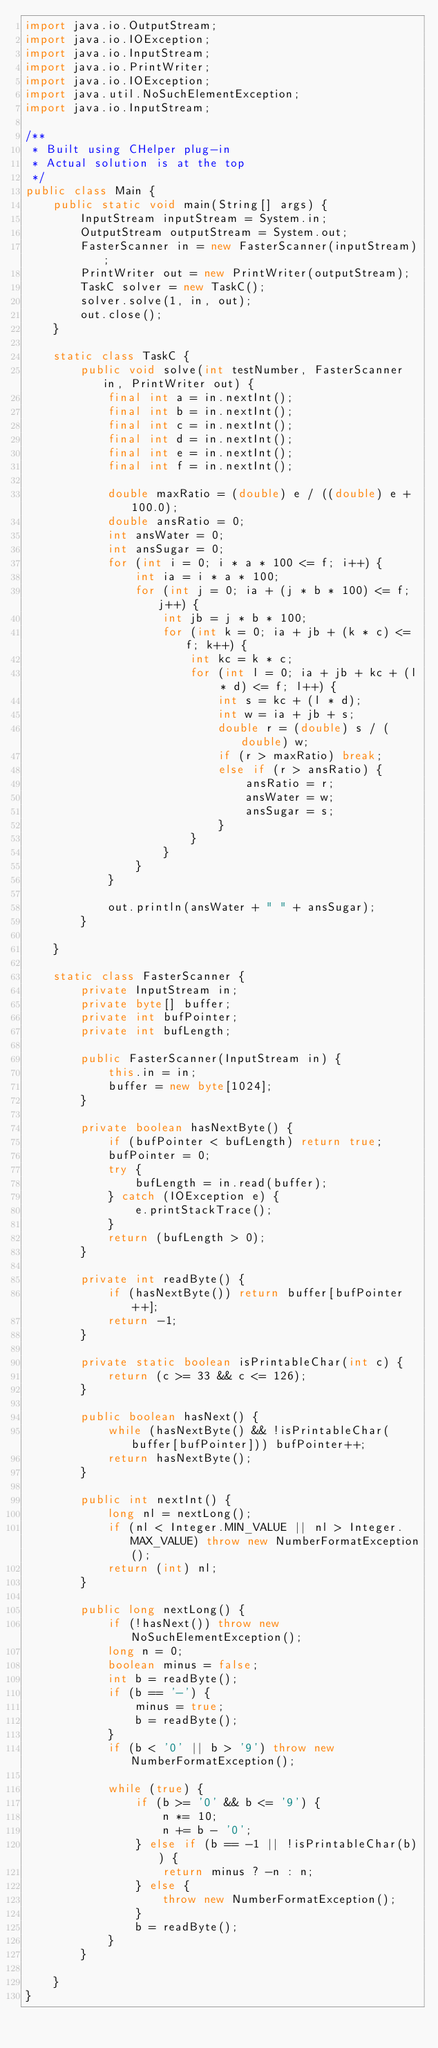Convert code to text. <code><loc_0><loc_0><loc_500><loc_500><_Java_>import java.io.OutputStream;
import java.io.IOException;
import java.io.InputStream;
import java.io.PrintWriter;
import java.io.IOException;
import java.util.NoSuchElementException;
import java.io.InputStream;

/**
 * Built using CHelper plug-in
 * Actual solution is at the top
 */
public class Main {
    public static void main(String[] args) {
        InputStream inputStream = System.in;
        OutputStream outputStream = System.out;
        FasterScanner in = new FasterScanner(inputStream);
        PrintWriter out = new PrintWriter(outputStream);
        TaskC solver = new TaskC();
        solver.solve(1, in, out);
        out.close();
    }

    static class TaskC {
        public void solve(int testNumber, FasterScanner in, PrintWriter out) {
            final int a = in.nextInt();
            final int b = in.nextInt();
            final int c = in.nextInt();
            final int d = in.nextInt();
            final int e = in.nextInt();
            final int f = in.nextInt();

            double maxRatio = (double) e / ((double) e + 100.0);
            double ansRatio = 0;
            int ansWater = 0;
            int ansSugar = 0;
            for (int i = 0; i * a * 100 <= f; i++) {
                int ia = i * a * 100;
                for (int j = 0; ia + (j * b * 100) <= f; j++) {
                    int jb = j * b * 100;
                    for (int k = 0; ia + jb + (k * c) <= f; k++) {
                        int kc = k * c;
                        for (int l = 0; ia + jb + kc + (l * d) <= f; l++) {
                            int s = kc + (l * d);
                            int w = ia + jb + s;
                            double r = (double) s / (double) w;
                            if (r > maxRatio) break;
                            else if (r > ansRatio) {
                                ansRatio = r;
                                ansWater = w;
                                ansSugar = s;
                            }
                        }
                    }
                }
            }

            out.println(ansWater + " " + ansSugar);
        }

    }

    static class FasterScanner {
        private InputStream in;
        private byte[] buffer;
        private int bufPointer;
        private int bufLength;

        public FasterScanner(InputStream in) {
            this.in = in;
            buffer = new byte[1024];
        }

        private boolean hasNextByte() {
            if (bufPointer < bufLength) return true;
            bufPointer = 0;
            try {
                bufLength = in.read(buffer);
            } catch (IOException e) {
                e.printStackTrace();
            }
            return (bufLength > 0);
        }

        private int readByte() {
            if (hasNextByte()) return buffer[bufPointer++];
            return -1;
        }

        private static boolean isPrintableChar(int c) {
            return (c >= 33 && c <= 126);
        }

        public boolean hasNext() {
            while (hasNextByte() && !isPrintableChar(buffer[bufPointer])) bufPointer++;
            return hasNextByte();
        }

        public int nextInt() {
            long nl = nextLong();
            if (nl < Integer.MIN_VALUE || nl > Integer.MAX_VALUE) throw new NumberFormatException();
            return (int) nl;
        }

        public long nextLong() {
            if (!hasNext()) throw new NoSuchElementException();
            long n = 0;
            boolean minus = false;
            int b = readByte();
            if (b == '-') {
                minus = true;
                b = readByte();
            }
            if (b < '0' || b > '9') throw new NumberFormatException();

            while (true) {
                if (b >= '0' && b <= '9') {
                    n *= 10;
                    n += b - '0';
                } else if (b == -1 || !isPrintableChar(b)) {
                    return minus ? -n : n;
                } else {
                    throw new NumberFormatException();
                }
                b = readByte();
            }
        }

    }
}

</code> 